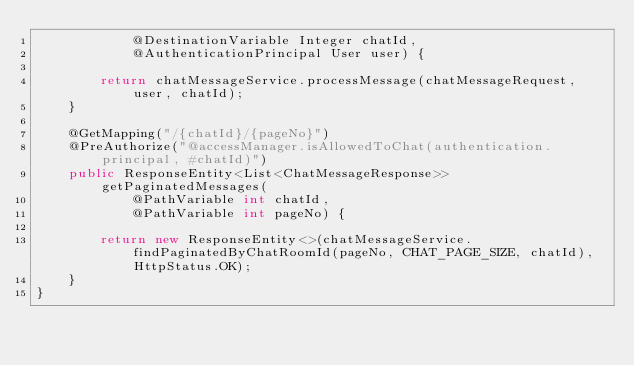<code> <loc_0><loc_0><loc_500><loc_500><_Java_>            @DestinationVariable Integer chatId,
            @AuthenticationPrincipal User user) {

        return chatMessageService.processMessage(chatMessageRequest, user, chatId);
    }

    @GetMapping("/{chatId}/{pageNo}")
    @PreAuthorize("@accessManager.isAllowedToChat(authentication.principal, #chatId)")
    public ResponseEntity<List<ChatMessageResponse>> getPaginatedMessages(
            @PathVariable int chatId,
            @PathVariable int pageNo) {

        return new ResponseEntity<>(chatMessageService.findPaginatedByChatRoomId(pageNo, CHAT_PAGE_SIZE, chatId), HttpStatus.OK);
    }
}
</code> 